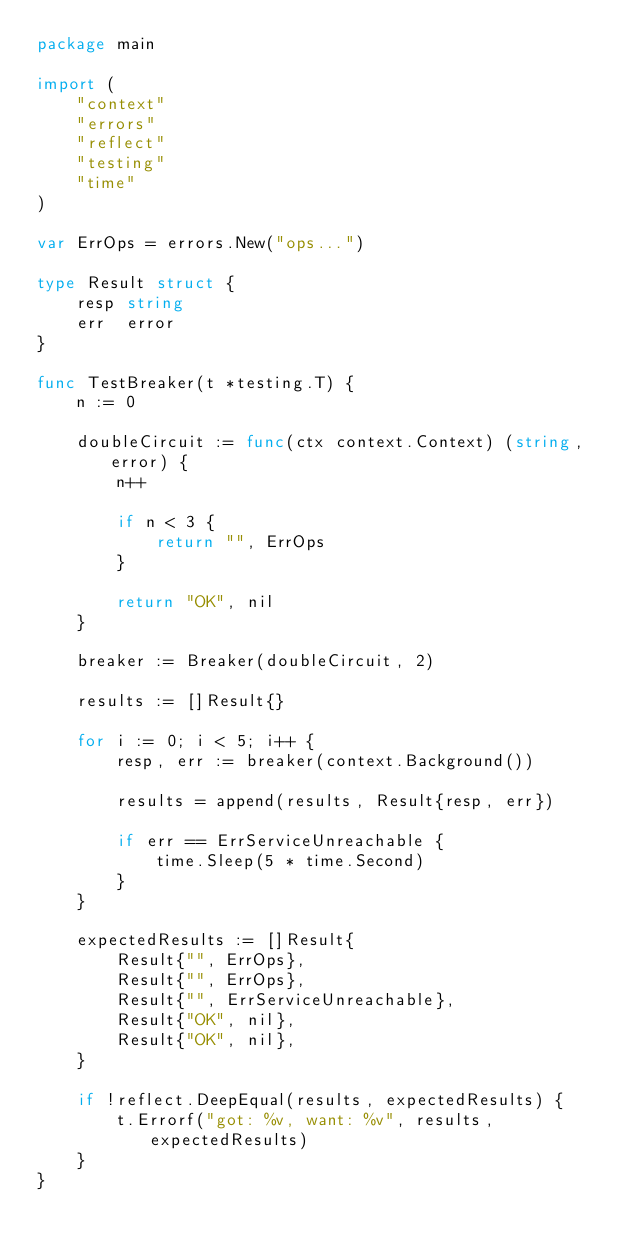Convert code to text. <code><loc_0><loc_0><loc_500><loc_500><_Go_>package main

import (
	"context"
	"errors"
	"reflect"
	"testing"
	"time"
)

var ErrOps = errors.New("ops...")

type Result struct {
	resp string
	err  error
}

func TestBreaker(t *testing.T) {
	n := 0

	doubleCircuit := func(ctx context.Context) (string, error) {
		n++

		if n < 3 {
			return "", ErrOps
		}

		return "OK", nil
	}

	breaker := Breaker(doubleCircuit, 2)

	results := []Result{}

	for i := 0; i < 5; i++ {
		resp, err := breaker(context.Background())

		results = append(results, Result{resp, err})

		if err == ErrServiceUnreachable {
			time.Sleep(5 * time.Second)
		}
	}

	expectedResults := []Result{
		Result{"", ErrOps},
		Result{"", ErrOps},
		Result{"", ErrServiceUnreachable},
		Result{"OK", nil},
		Result{"OK", nil},
	}

	if !reflect.DeepEqual(results, expectedResults) {
		t.Errorf("got: %v, want: %v", results, expectedResults)
	}
}
</code> 